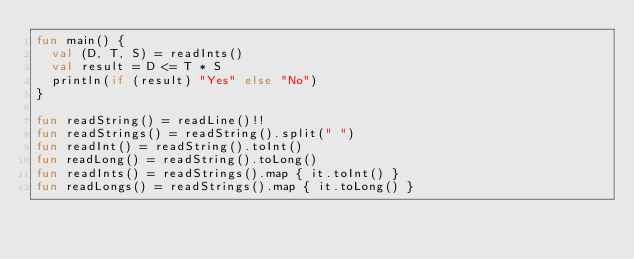Convert code to text. <code><loc_0><loc_0><loc_500><loc_500><_Kotlin_>fun main() {
  val (D, T, S) = readInts()
  val result = D <= T * S
  println(if (result) "Yes" else "No")
}

fun readString() = readLine()!!
fun readStrings() = readString().split(" ")
fun readInt() = readString().toInt()
fun readLong() = readString().toLong()
fun readInts() = readStrings().map { it.toInt() }
fun readLongs() = readStrings().map { it.toLong() }
</code> 